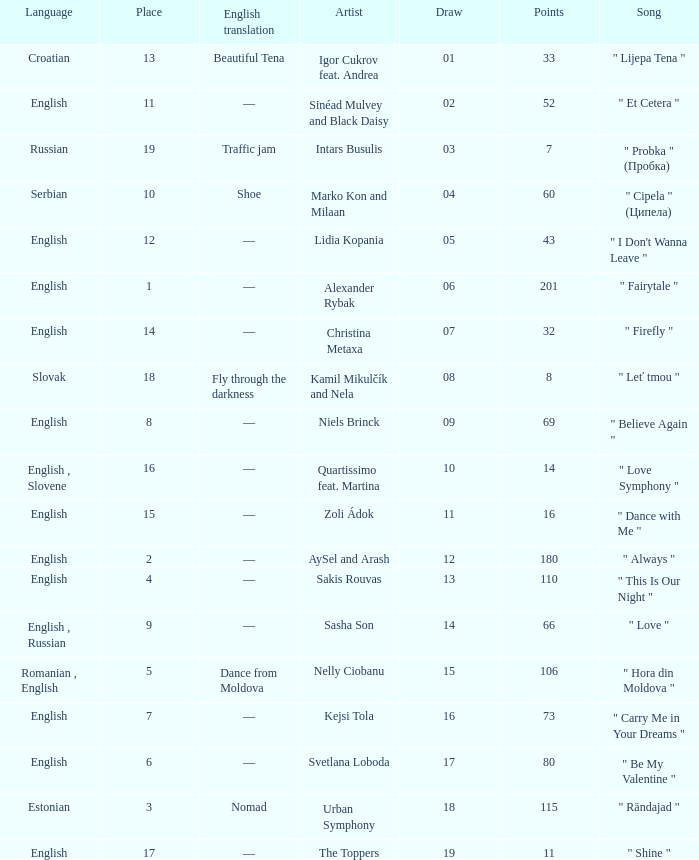What is the english translation when the language is english, draw is smaller than 16, and the artist is aysel and arash? —. 